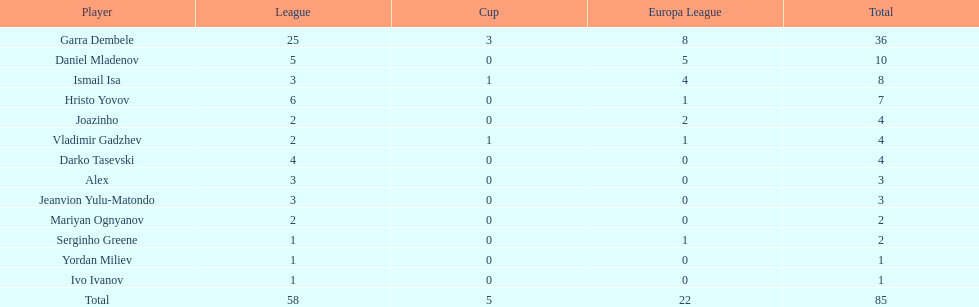Which player is in the same league as joazinho and vladimir gadzhev? Mariyan Ognyanov. 